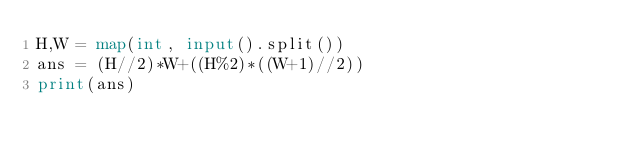<code> <loc_0><loc_0><loc_500><loc_500><_Python_>H,W = map(int, input().split())
ans = (H//2)*W+((H%2)*((W+1)//2))
print(ans)</code> 